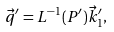<formula> <loc_0><loc_0><loc_500><loc_500>\vec { q } ^ { \prime } = L ^ { - 1 } ( P ^ { \prime } ) \vec { k } _ { 1 } ^ { \prime } ,</formula> 